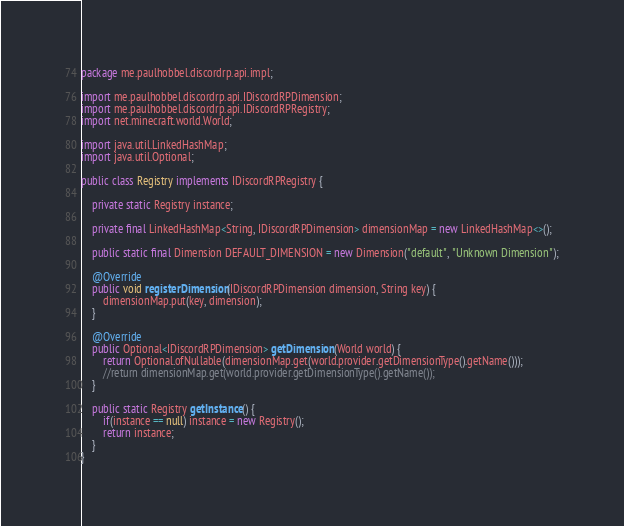Convert code to text. <code><loc_0><loc_0><loc_500><loc_500><_Java_>package me.paulhobbel.discordrp.api.impl;

import me.paulhobbel.discordrp.api.IDiscordRPDimension;
import me.paulhobbel.discordrp.api.IDiscordRPRegistry;
import net.minecraft.world.World;

import java.util.LinkedHashMap;
import java.util.Optional;

public class Registry implements IDiscordRPRegistry {

    private static Registry instance;

    private final LinkedHashMap<String, IDiscordRPDimension> dimensionMap = new LinkedHashMap<>();

    public static final Dimension DEFAULT_DIMENSION = new Dimension("default", "Unknown Dimension");

    @Override
    public void registerDimension(IDiscordRPDimension dimension, String key) {
        dimensionMap.put(key, dimension);
    }

    @Override
    public Optional<IDiscordRPDimension> getDimension(World world) {
        return Optional.ofNullable(dimensionMap.get(world.provider.getDimensionType().getName()));
        //return dimensionMap.get(world.provider.getDimensionType().getName());
    }

    public static Registry getInstance() {
        if(instance == null) instance = new Registry();
        return instance;
    }
}
</code> 